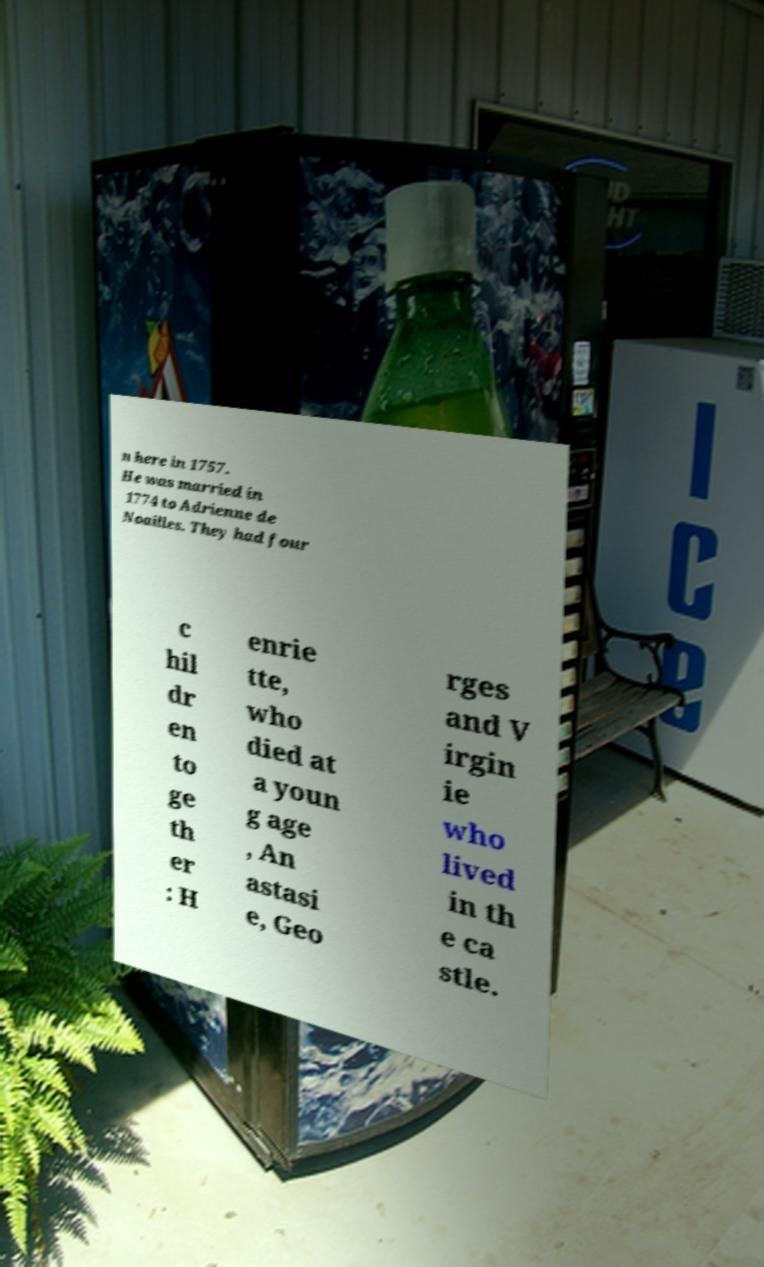Could you extract and type out the text from this image? n here in 1757. He was married in 1774 to Adrienne de Noailles. They had four c hil dr en to ge th er : H enrie tte, who died at a youn g age , An astasi e, Geo rges and V irgin ie who lived in th e ca stle. 